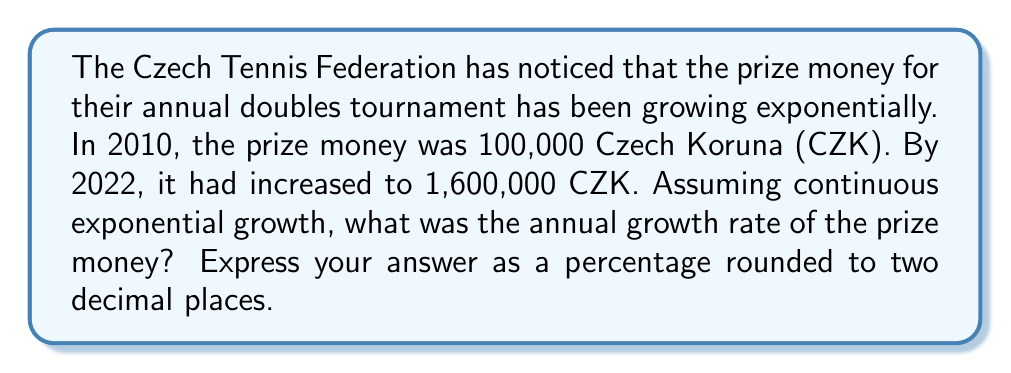Solve this math problem. Let's approach this step-by-step using logarithms:

1) The exponential growth formula is:
   $A = P(1 + r)^t$
   Where A is the final amount, P is the initial amount, r is the annual growth rate, and t is the time in years.

2) Plugging in our values:
   $1,600,000 = 100,000(1 + r)^{12}$

3) Dividing both sides by 100,000:
   $16 = (1 + r)^{12}$

4) Taking the natural log of both sides:
   $\ln(16) = 12\ln(1 + r)$

5) Using the logarithm property $\ln(a^b) = b\ln(a)$:
   $\ln(16) = 12\ln(1 + r)$

6) Dividing both sides by 12:
   $\frac{\ln(16)}{12} = \ln(1 + r)$

7) Taking $e$ to the power of both sides:
   $e^{\frac{\ln(16)}{12}} = e^{\ln(1 + r)} = 1 + r$

8) Subtracting 1 from both sides:
   $e^{\frac{\ln(16)}{12}} - 1 = r$

9) Calculating:
   $r = e^{\frac{\ln(16)}{12}} - 1 \approx 0.2336$

10) Converting to a percentage:
    $0.2336 * 100 \approx 23.36\%$
Answer: 23.36% 